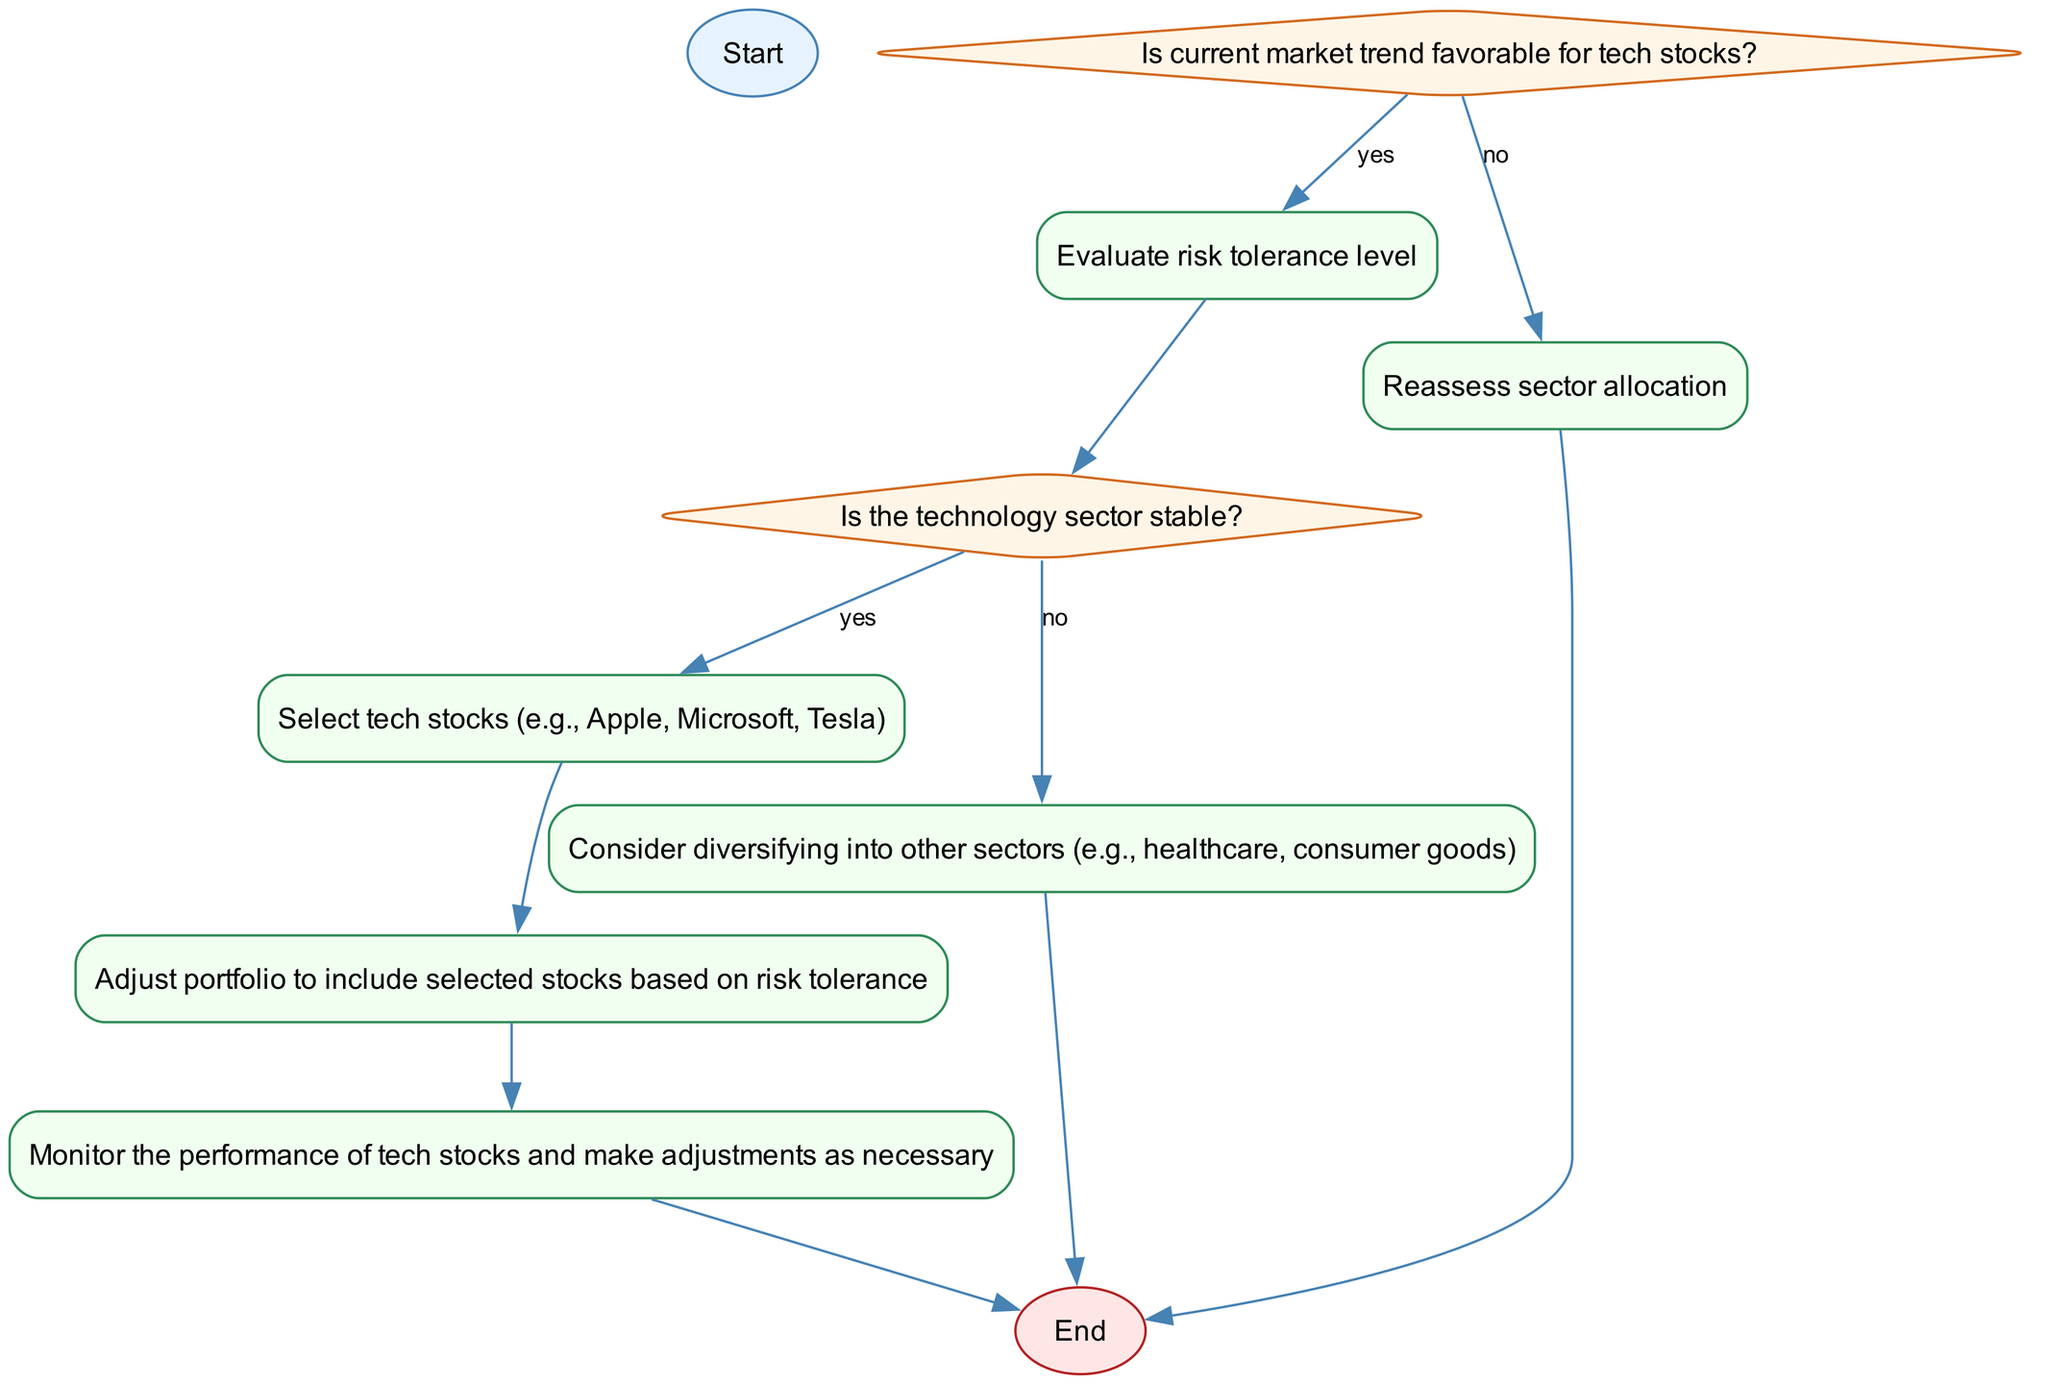What is the first step in the decision-making process? The first step is represented by the "Start" node, indicating the initiation of the process. There are no other preceding steps before this node.
Answer: Start What happens if the current market trend is not favorable for tech stocks? If the market trend is unfavorable, the flowchart indicates that the next step is to "reassess sector." This means moving directly to this process without any evaluation of risk tolerance.
Answer: Reassess sector How many decision nodes are present in the diagram? The diagram contains three decision nodes: one for the market trend, one for the technology sector stability, and one indirectly assessing risk tolerance.
Answer: 3 What is the outcome if the technology sector is unstable? If the technology sector is determined to be unstable, the process leads to "diversify into other sectors," which directs the user to explore investments in sectors outside of technology.
Answer: Diversify non-tech Which process follows the evaluation of risk tolerance? After evaluating risk tolerance, the next step in the flowchart is "sector analysis." This is where the stability of the technology sector is assessed.
Answer: Sector analysis What is the last process before the end of the flowchart? The last process before reaching the end node is "monitor performance," which involves tracking the performance of the selected tech stocks and making adjustments as needed.
Answer: Monitor performance If tech stocks are selected, what is the next step? After selecting tech stocks, the next step is to "adjust portfolio" based on the evaluated risk tolerance. This ensures the portfolio aligns with the investor's risk profile and chosen stocks.
Answer: Adjust portfolio What type of process follows the "check market" decision? Following the "check market" decision, there is a process called "evaluate risk tolerance." This indicates a progression from determining the market climate to understanding the investor's risk capacity.
Answer: Evaluate risk tolerance 